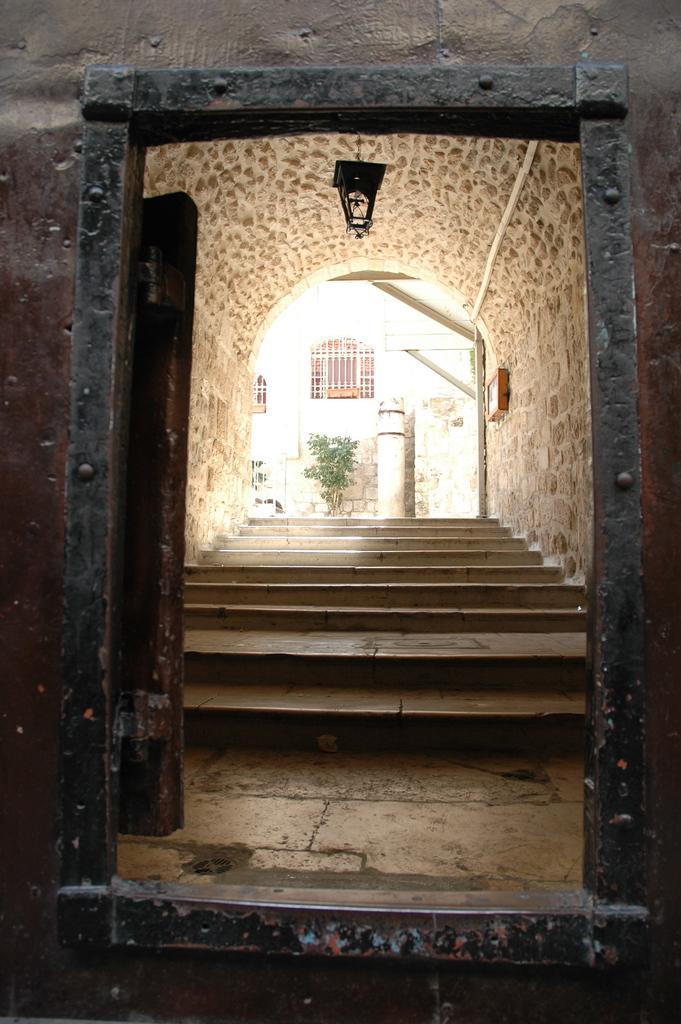Describe this image in one or two sentences. In this image we can see the entrance of a building. In the background of the image there is a plant, window, steps and other objects. On the left and right side of the image there is a wall. At the top and bottom of the image there is a wall. 